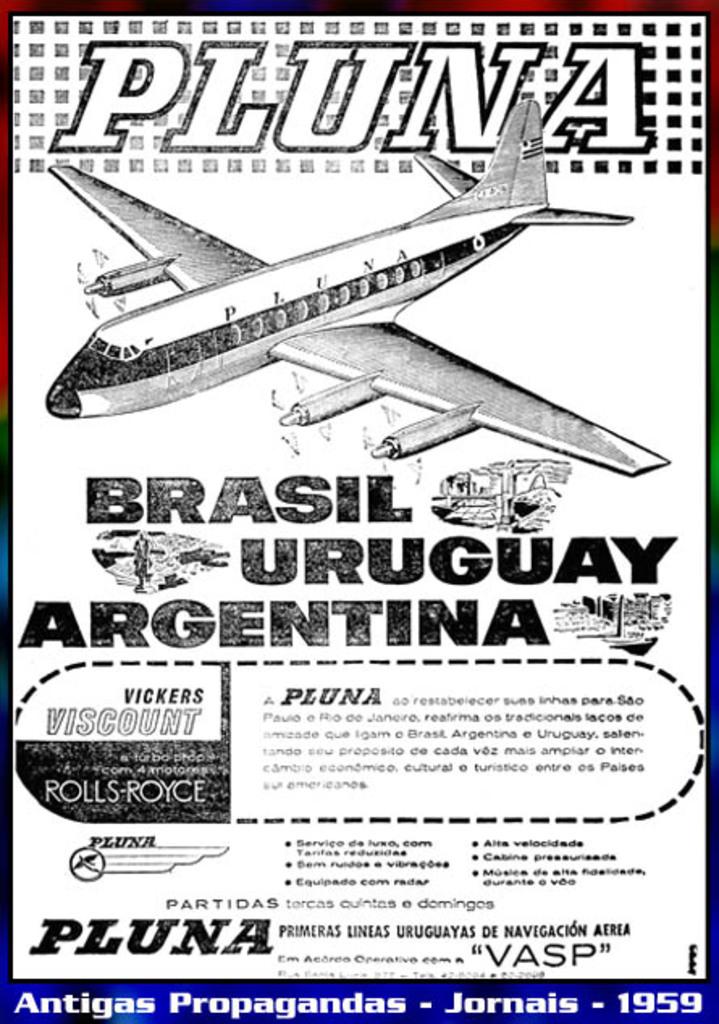Where to visit first? brasil, uruguay or argentina?
Make the answer very short. Pluna. What is the year on the poster?
Your answer should be very brief. 1959. 